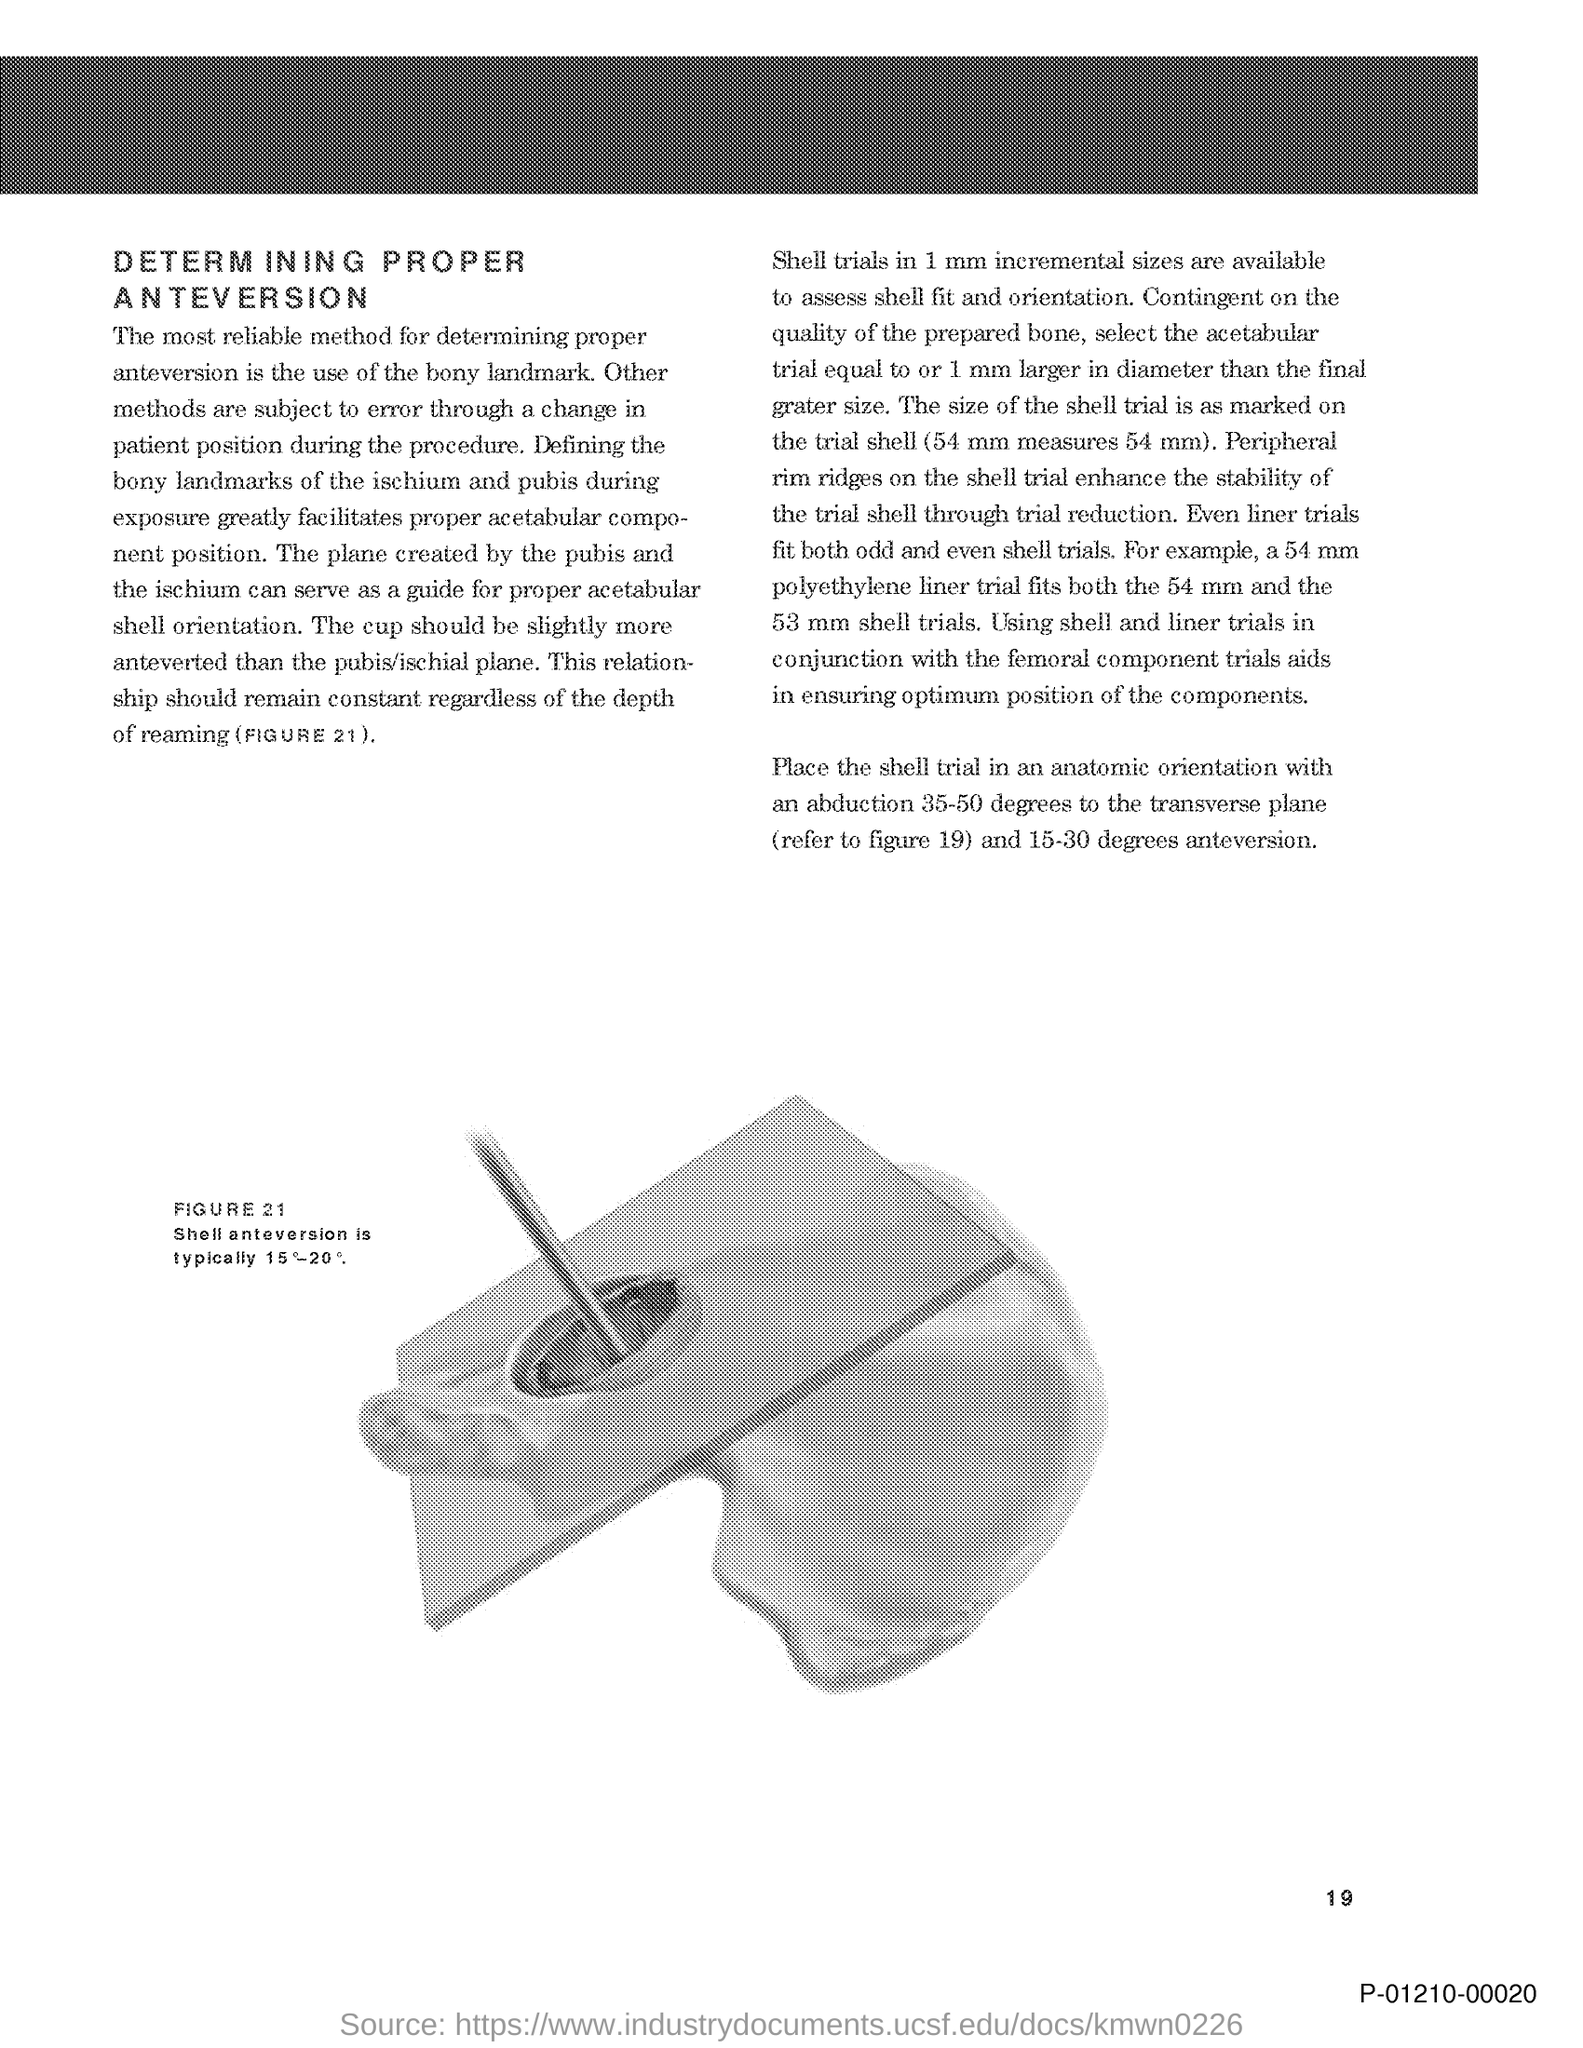Identify some key points in this picture. The page number is 19. 